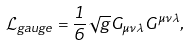Convert formula to latex. <formula><loc_0><loc_0><loc_500><loc_500>\mathcal { L } _ { g a u g e } = \frac { 1 } { 6 } \sqrt { g } G _ { \mu \nu \lambda } G ^ { \mu \nu \lambda } ,</formula> 